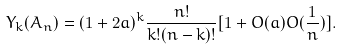Convert formula to latex. <formula><loc_0><loc_0><loc_500><loc_500>Y _ { k } ( A _ { n } ) = ( 1 + 2 a ) ^ { k } \frac { n ! } { k ! ( n - k ) ! } [ 1 + O ( a ) O ( \frac { 1 } { n } ) ] .</formula> 